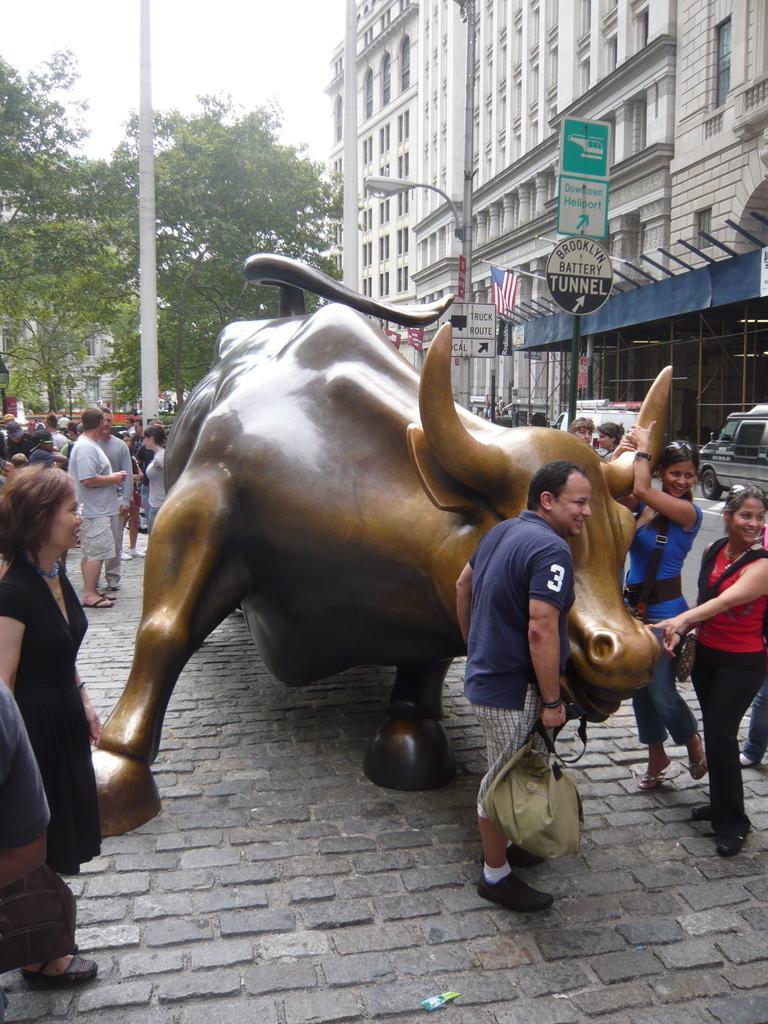In one or two sentences, can you explain what this image depicts? In the image in the center, we can see on the statue. And we can see a few people are standing and holding some objects. In the background, we can see the sky, clouds, trees, buildings, poles, sign boards and flags. 